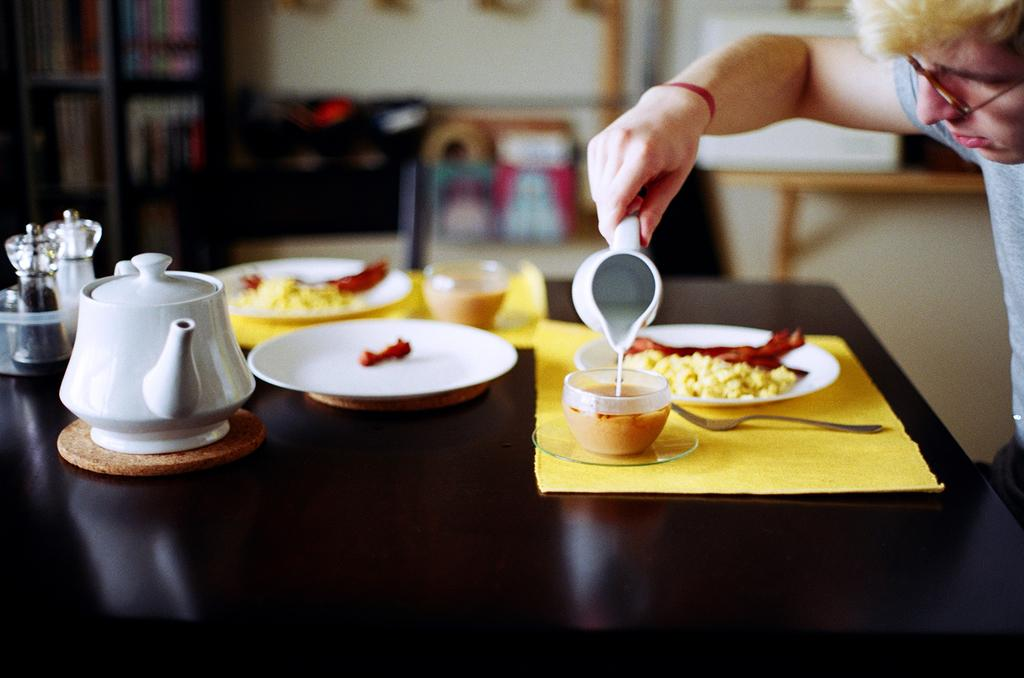What objects are on the table in the image? There are jars, a kettle, plates, food, cups, a mat, and a spoon on the table. What is the person holding on the table? The person is holding a cup on the table. What can be seen in the background of the image? There is a wall in the background. What type of toothpaste is being used by the person in the image? There is no toothpaste present in the image; it features a table with various objects and a person holding a cup. What game is the person playing on the table? There is no game or play activity depicted in the image; it shows a table with various objects and a person holding a cup. 